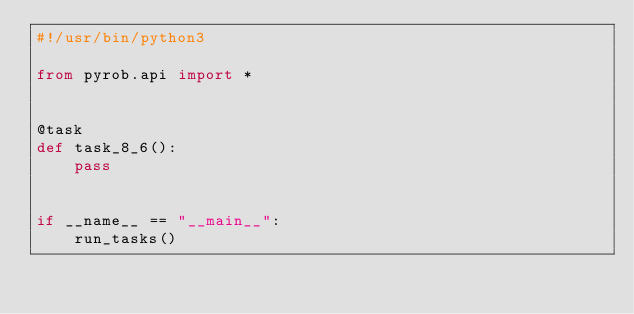<code> <loc_0><loc_0><loc_500><loc_500><_Python_>#!/usr/bin/python3

from pyrob.api import *


@task
def task_8_6():
    pass


if __name__ == "__main__":
    run_tasks()
</code> 